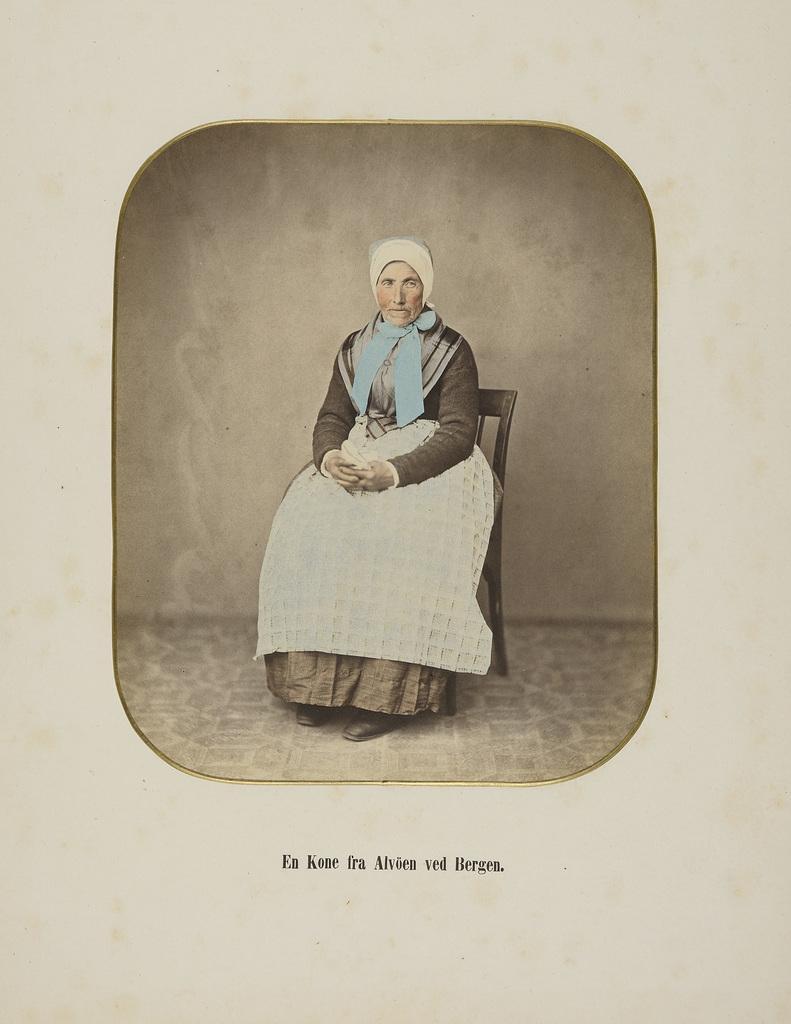Can you describe this image briefly? There is an image of a woman sitting on a chair. Something written at the bottom. 